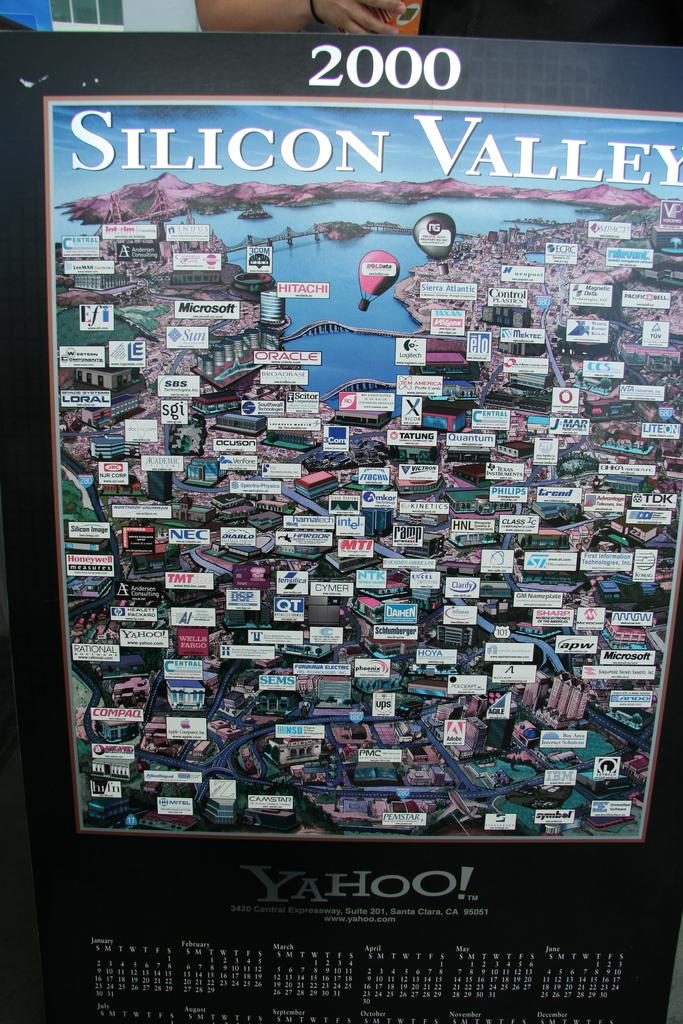<image>
Present a compact description of the photo's key features. A map of Silcon Valley on a 2000 calendar. 